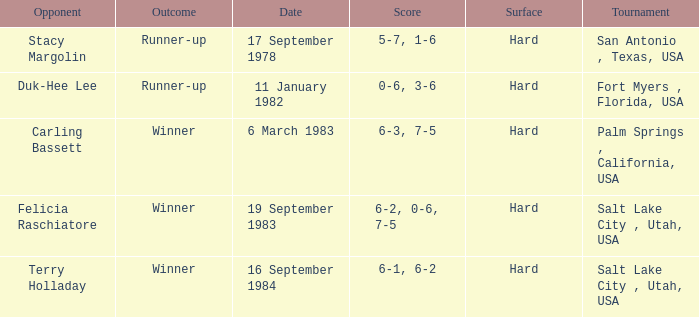What was the outcome of the match against Stacy Margolin? Runner-up. 